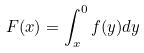<formula> <loc_0><loc_0><loc_500><loc_500>F ( x ) = \int _ { x } ^ { 0 } f ( y ) d y</formula> 